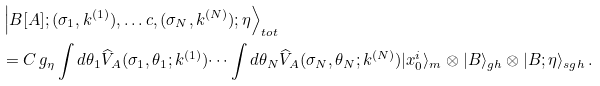<formula> <loc_0><loc_0><loc_500><loc_500>& \left | B [ A ] ; ( \sigma _ { 1 } , k ^ { ( 1 ) } ) , \dots c , ( \sigma _ { N } , k ^ { ( N ) } ) ; \eta \right \rangle _ { t o t } \\ & = C \, g _ { \eta } \int { d } \theta _ { 1 } \widehat { V } _ { A } ( \sigma _ { 1 } , \theta _ { 1 } ; k ^ { ( 1 ) } ) \dots \int { d } \theta _ { N } \widehat { V } _ { A } ( \sigma _ { N } , \theta _ { N } ; k ^ { ( N ) } ) | x ^ { i } _ { 0 } \rangle _ { m } \otimes | B \rangle _ { g h } \otimes | B ; \eta \rangle _ { s g h } \, .</formula> 